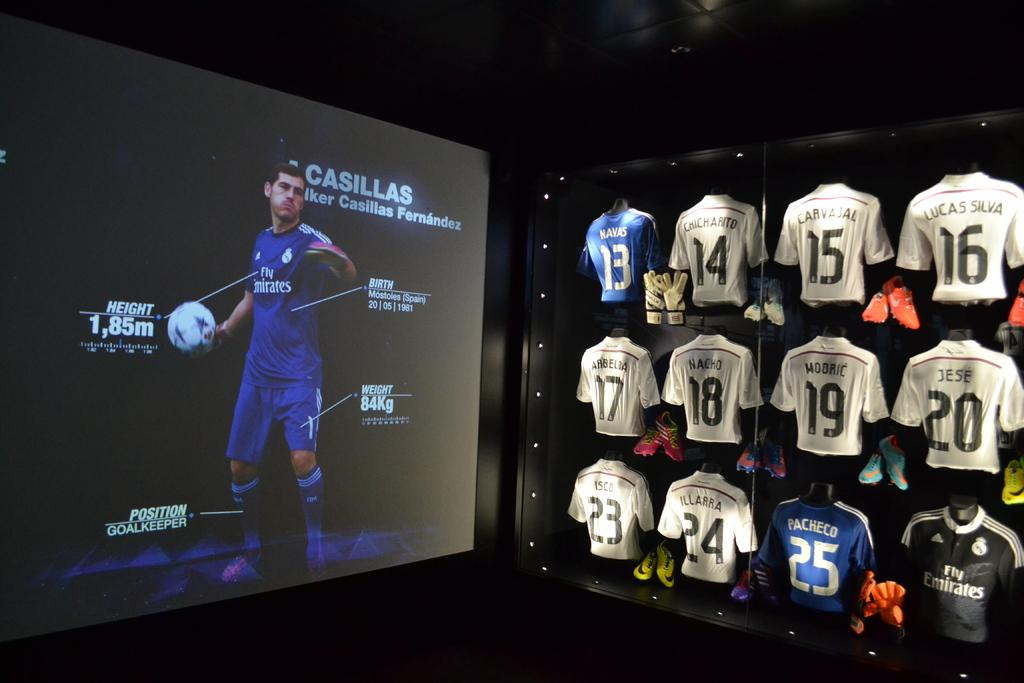<image>
Give a short and clear explanation of the subsequent image. A football player advertises sports clothing and he stands at 1.85 metres tall. 